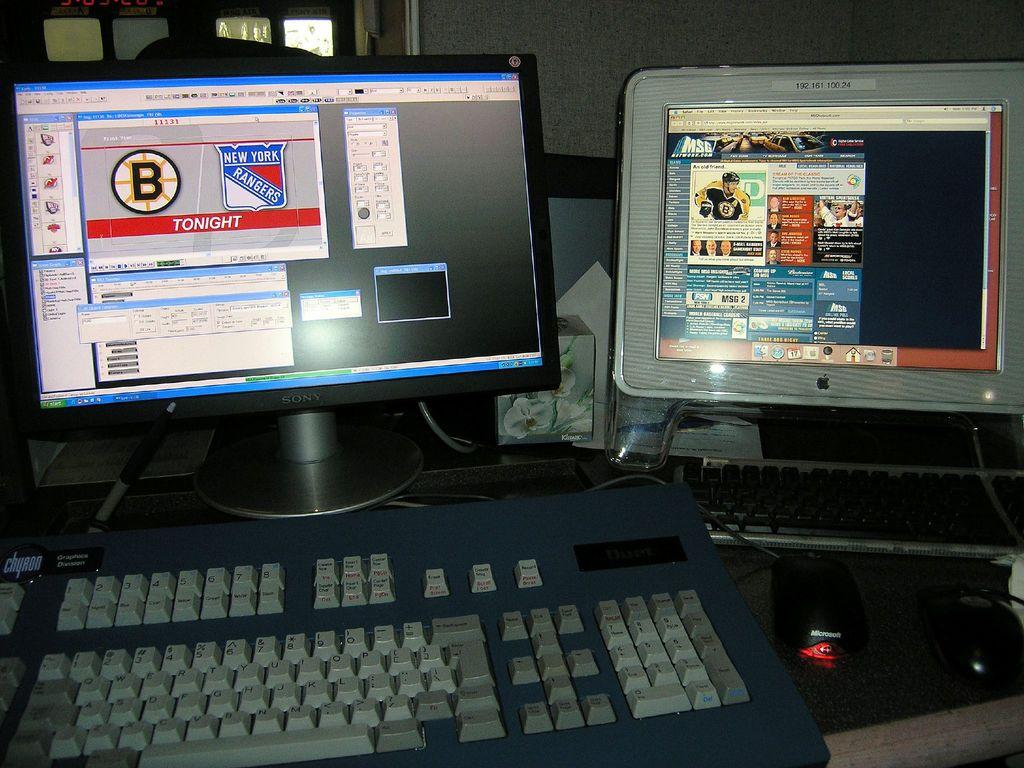<image>
Write a terse but informative summary of the picture. Boston at Rangers is shown on the web page of this laptop. 